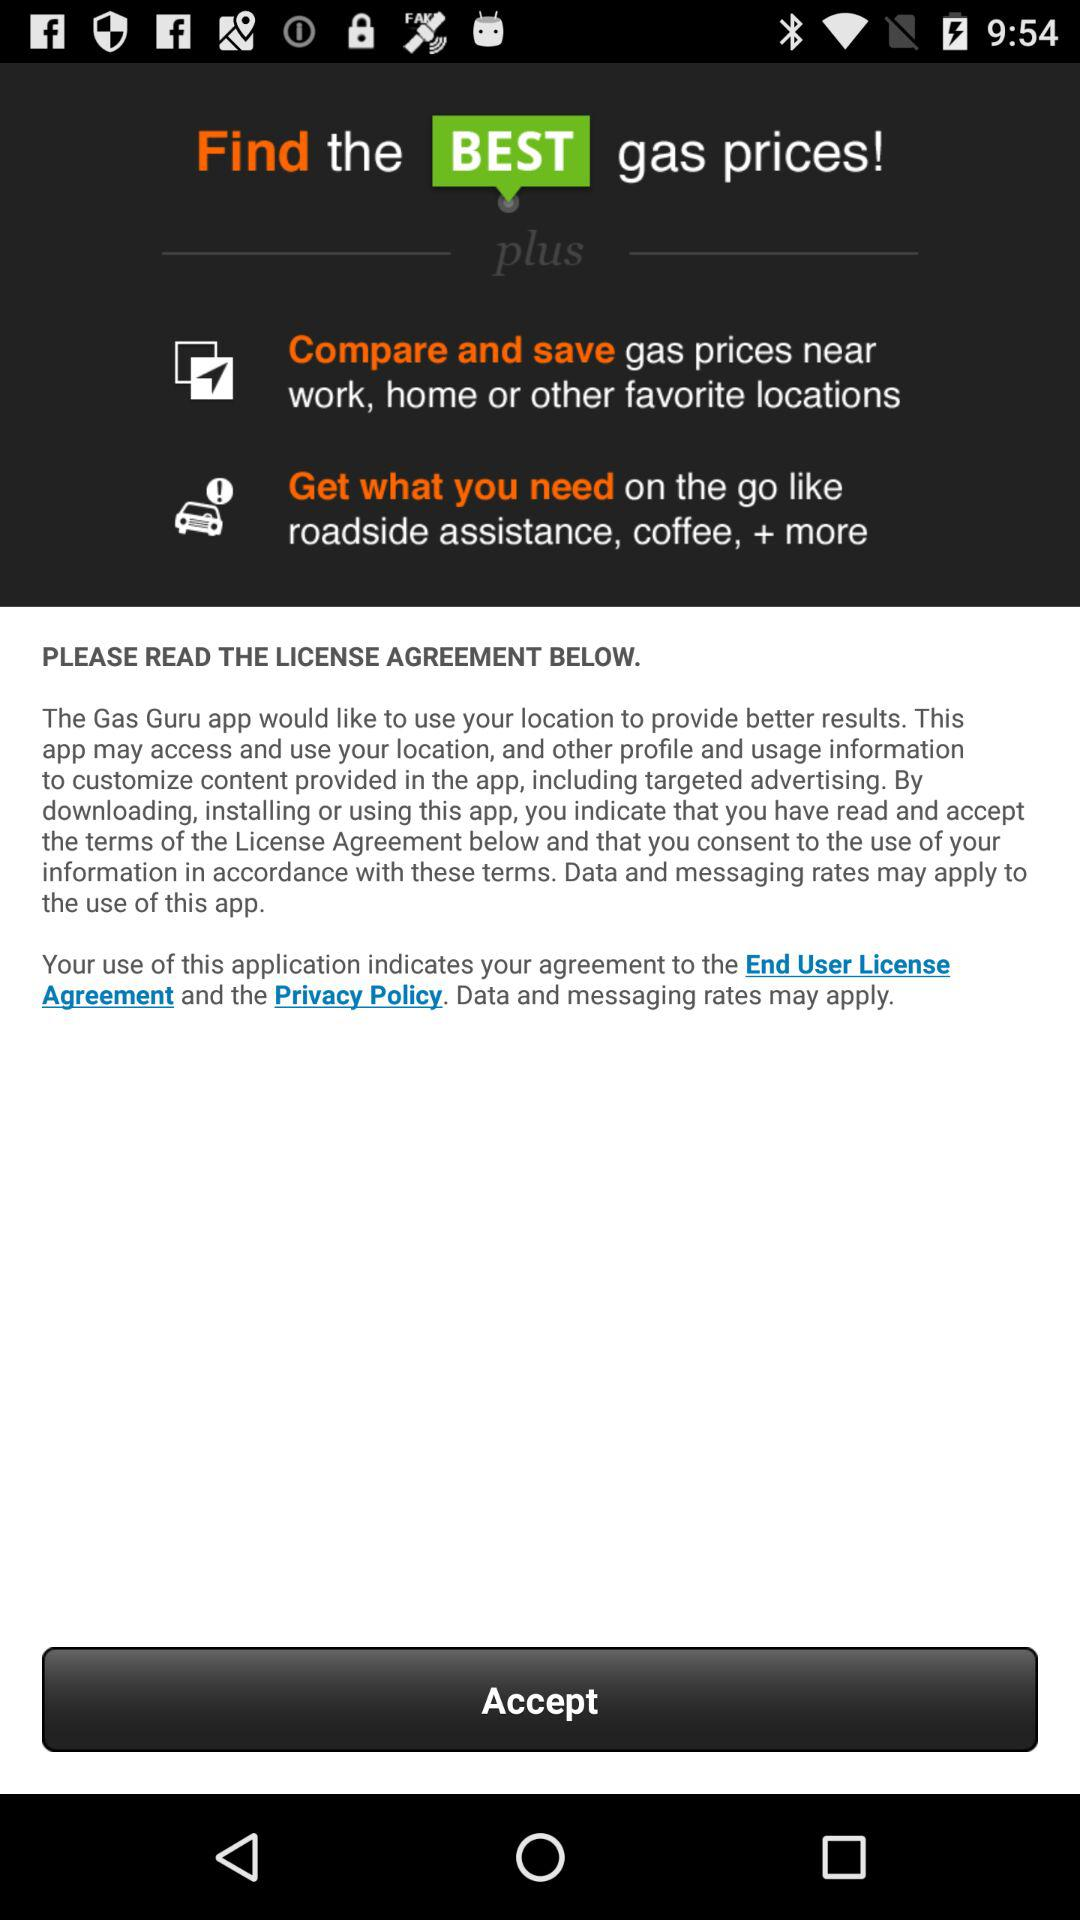What is the name of the app? The name of the app is "Gas Guru". 